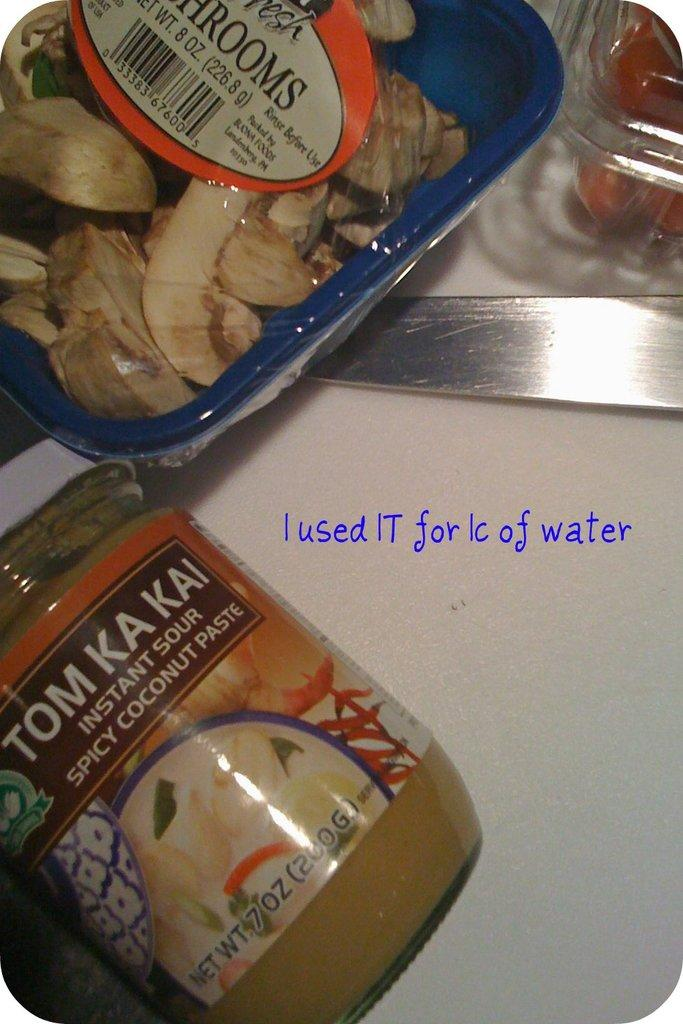What objects are on the table in the image? There is a jar, a box, and a knife on the table in the image. Can you describe the jar in the image? The jar is an object on the table, but no further details are provided. What else is on the table besides the jar? There is a box and a knife on the table in the image. What channel is the hopeful rainstorm broadcasting on in the image? There is no mention of a channel, hope, or rainstorm in the image. The image only features a jar, a box, and a knife on a table. 